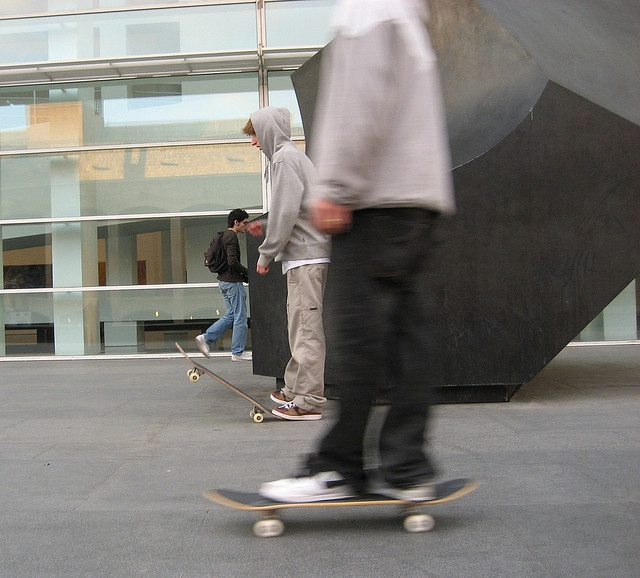Describe the objects in this image and their specific colors. I can see people in lightgray, black, and darkgray tones, people in lightgray, darkgray, and gray tones, skateboard in lightgray, gray, and darkgray tones, people in lightgray, black, gray, and darkgray tones, and skateboard in lightgray, gray, and darkgray tones in this image. 